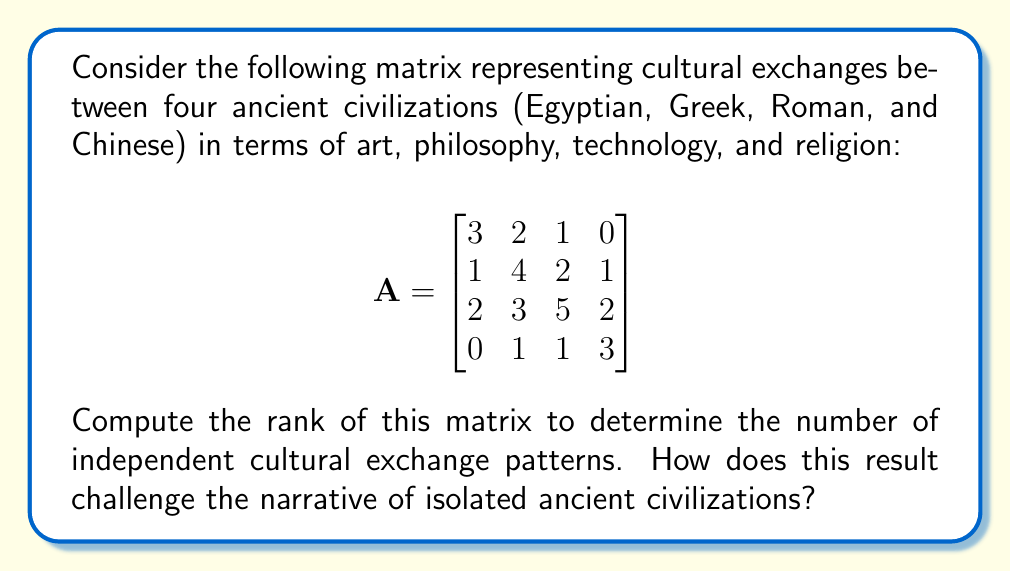Can you answer this question? To find the rank of matrix A, we'll use the Gaussian elimination method to transform it into row echelon form:

Step 1: Start with the original matrix
$$A = \begin{bmatrix}
3 & 2 & 1 & 0 \\
1 & 4 & 2 & 1 \\
2 & 3 & 5 & 2 \\
0 & 1 & 1 & 3
\end{bmatrix}$$

Step 2: Use the first row as a pivot to eliminate elements below it
$$\begin{bmatrix}
3 & 2 & 1 & 0 \\
0 & \frac{10}{3} & \frac{5}{3} & 1 \\
0 & \frac{5}{3} & \frac{13}{3} & 2 \\
0 & 1 & 1 & 3
\end{bmatrix}$$

Step 3: Use the second row as a pivot
$$\begin{bmatrix}
3 & 2 & 1 & 0 \\
0 & \frac{10}{3} & \frac{5}{3} & 1 \\
0 & 0 & \frac{14}{5} & \frac{1}{5} \\
0 & 0 & \frac{1}{3} & \frac{8}{3}
\end{bmatrix}$$

Step 4: Use the third row as a pivot
$$\begin{bmatrix}
3 & 2 & 1 & 0 \\
0 & \frac{10}{3} & \frac{5}{3} & 1 \\
0 & 0 & \frac{14}{5} & \frac{1}{5} \\
0 & 0 & 0 & \frac{119}{42}
\end{bmatrix}$$

The matrix is now in row echelon form. The rank of the matrix is equal to the number of non-zero rows, which is 4.

This result challenges the narrative of isolated ancient civilizations by showing that there were 4 independent patterns of cultural exchange, indicating a complex and interconnected network of interactions between these civilizations across various aspects of culture.
Answer: Rank = 4 